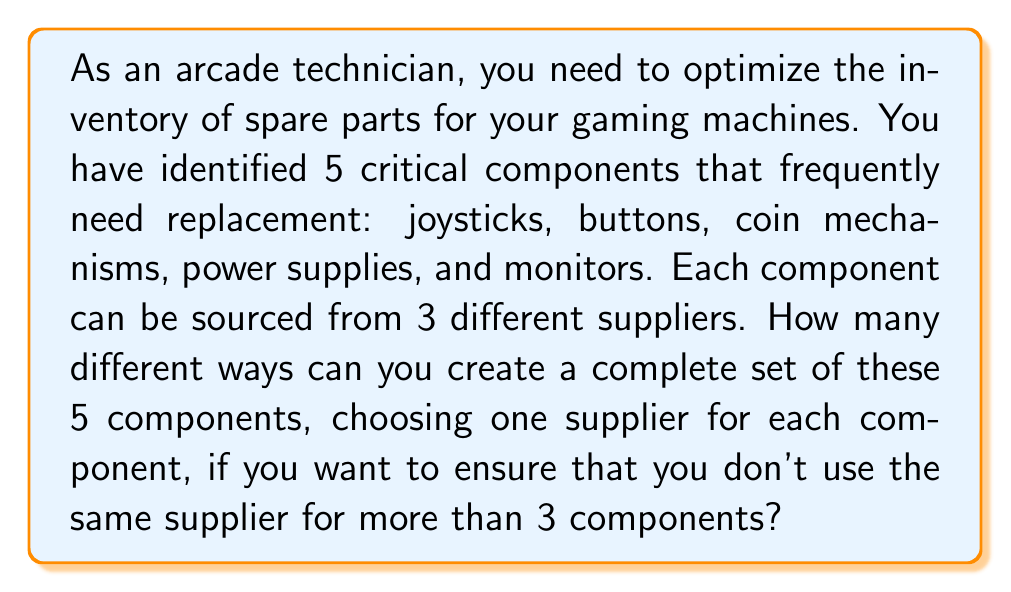Could you help me with this problem? Let's approach this problem using set theory and combinatorics:

1) First, we need to understand what we're counting. We're looking for the number of ways to choose suppliers for 5 components, with the constraint that no more than 3 components can come from the same supplier.

2) Let's consider the complement of this situation: it's easier to count the number of ways where at least 4 components come from the same supplier, and then subtract this from the total number of possible combinations.

3) Total number of possible combinations:
   Each component has 3 choices, and there are 5 components.
   Total combinations = $3^5 = 243$

4) Now, let's count the number of combinations where at least 4 components come from the same supplier:
   a) Choose the supplier: $\binom{3}{1} = 3$ ways
   b) Choose which 4 or 5 components will come from this supplier:
      - All 5: $\binom{5}{5} = 1$ way
      - Any 4 out of 5: $\binom{5}{4} = 5$ ways
   c) For the case where 4 components come from one supplier, we need to choose a supplier for the remaining component: 2 ways (as it can't be the same supplier)

5) So, the number of combinations with at least 4 from the same supplier is:
   $3 \cdot (1 + 5 \cdot 2) = 3 \cdot 11 = 33$

6) Therefore, the number of valid combinations is:
   $243 - 33 = 210$
Answer: 210 different ways 